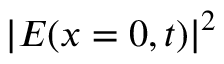<formula> <loc_0><loc_0><loc_500><loc_500>| E ( x = 0 , t ) | ^ { 2 }</formula> 